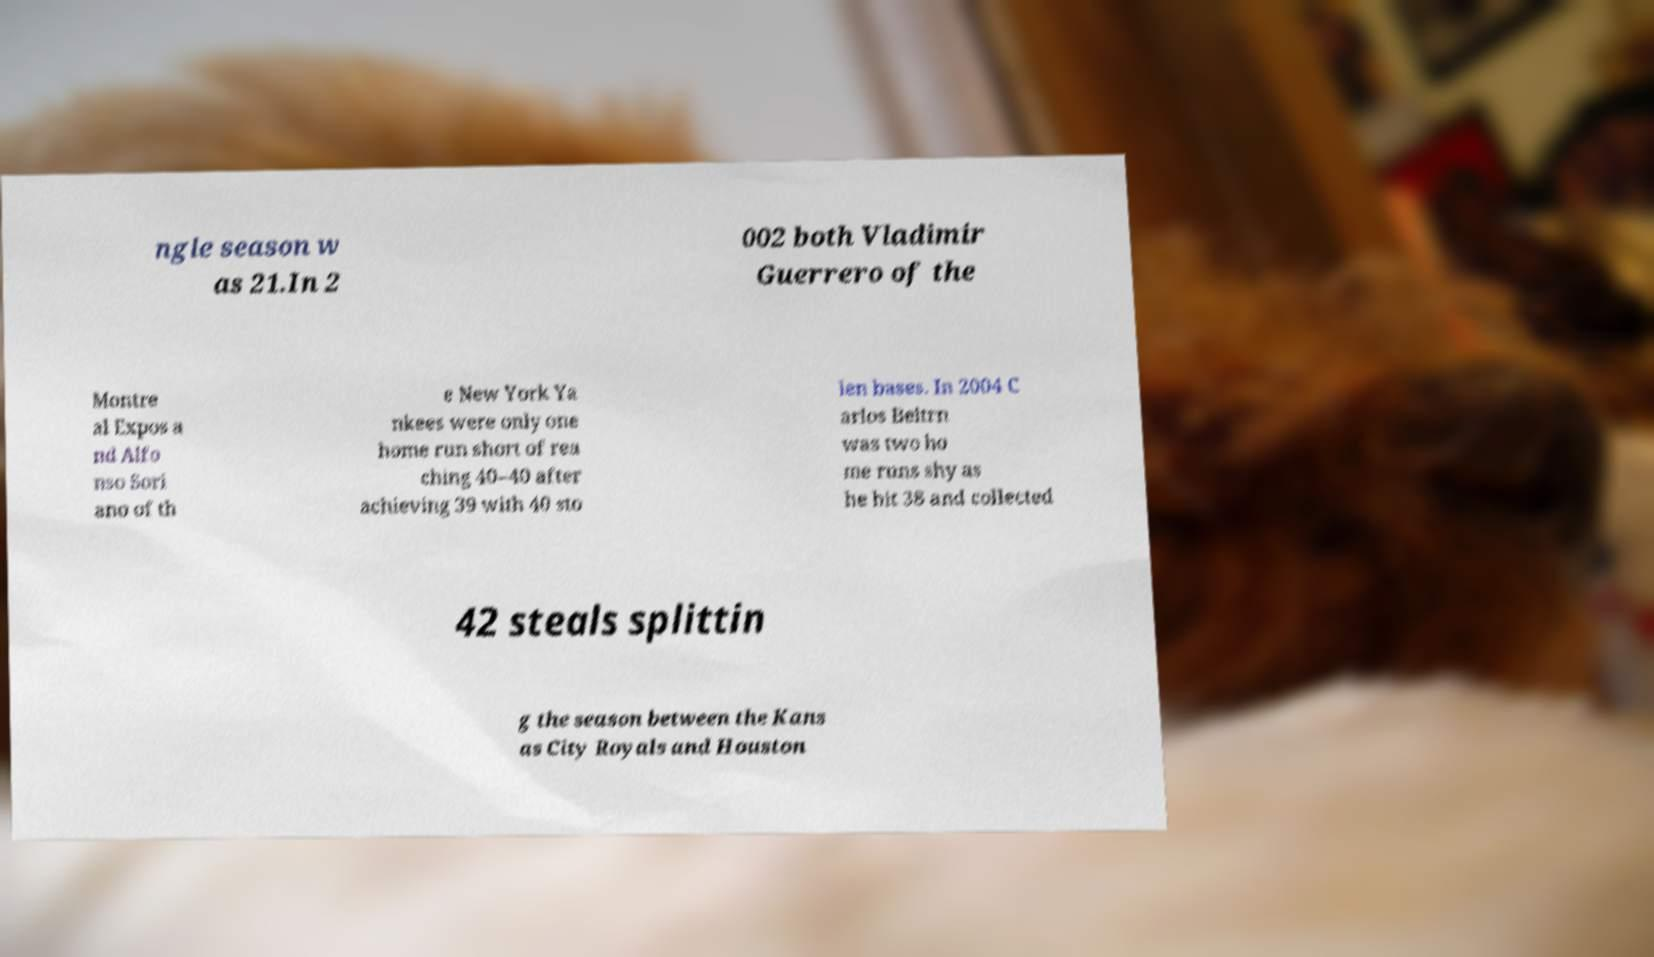Please identify and transcribe the text found in this image. ngle season w as 21.In 2 002 both Vladimir Guerrero of the Montre al Expos a nd Alfo nso Sori ano of th e New York Ya nkees were only one home run short of rea ching 40–40 after achieving 39 with 40 sto len bases. In 2004 C arlos Beltrn was two ho me runs shy as he hit 38 and collected 42 steals splittin g the season between the Kans as City Royals and Houston 